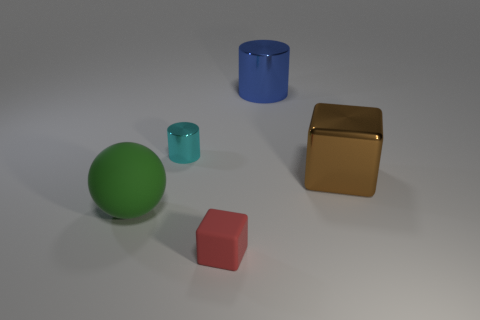How many matte objects are either large blocks or big yellow things?
Keep it short and to the point. 0. There is a big metal object to the right of the blue object; is it the same shape as the green rubber object?
Provide a succinct answer. No. Is the number of big cylinders in front of the big matte sphere greater than the number of big shiny cylinders?
Ensure brevity in your answer.  No. How many large things are both on the left side of the metallic cube and behind the green matte sphere?
Make the answer very short. 1. What is the color of the large thing that is on the left side of the block in front of the brown cube?
Provide a short and direct response. Green. How many other rubber blocks have the same color as the big cube?
Your answer should be compact. 0. Do the small metal cylinder and the large thing right of the big blue metallic cylinder have the same color?
Provide a succinct answer. No. Are there fewer large yellow rubber balls than large green balls?
Your response must be concise. Yes. Are there more big blue metal objects that are to the left of the cyan cylinder than small cyan cylinders that are in front of the small rubber thing?
Provide a short and direct response. No. Are the sphere and the big cube made of the same material?
Ensure brevity in your answer.  No. 